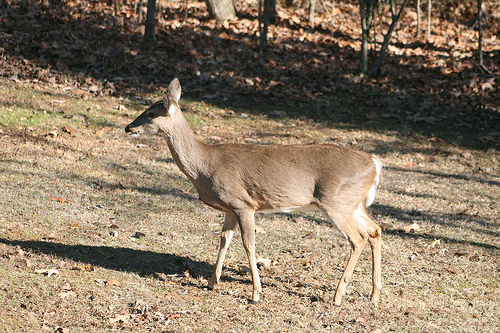<image>
Can you confirm if the dear is under the tree? No. The dear is not positioned under the tree. The vertical relationship between these objects is different. 